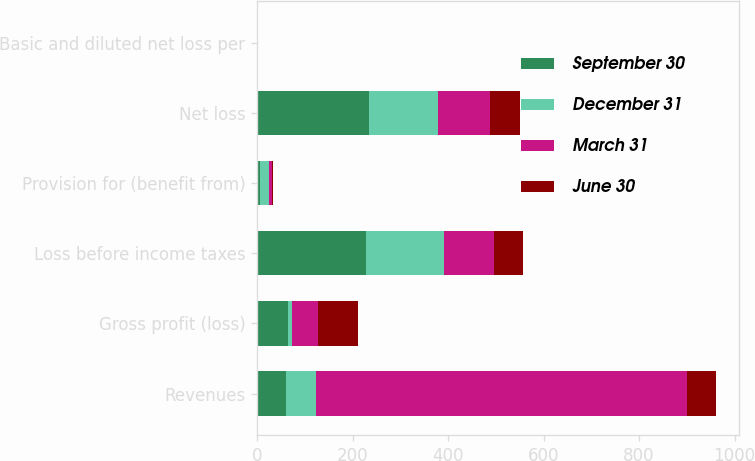Convert chart to OTSL. <chart><loc_0><loc_0><loc_500><loc_500><stacked_bar_chart><ecel><fcel>Revenues<fcel>Gross profit (loss)<fcel>Loss before income taxes<fcel>Provision for (benefit from)<fcel>Net loss<fcel>Basic and diluted net loss per<nl><fcel>September 30<fcel>61.3<fcel>65.2<fcel>229.1<fcel>5.8<fcel>234.9<fcel>0.74<nl><fcel>December 31<fcel>61.3<fcel>8.4<fcel>163.3<fcel>19.6<fcel>143.7<fcel>0.45<nl><fcel>March 31<fcel>778<fcel>55<fcel>103<fcel>5.6<fcel>108.6<fcel>0.34<nl><fcel>June 30<fcel>61.3<fcel>83.7<fcel>61.3<fcel>1.3<fcel>62.6<fcel>0.2<nl></chart> 